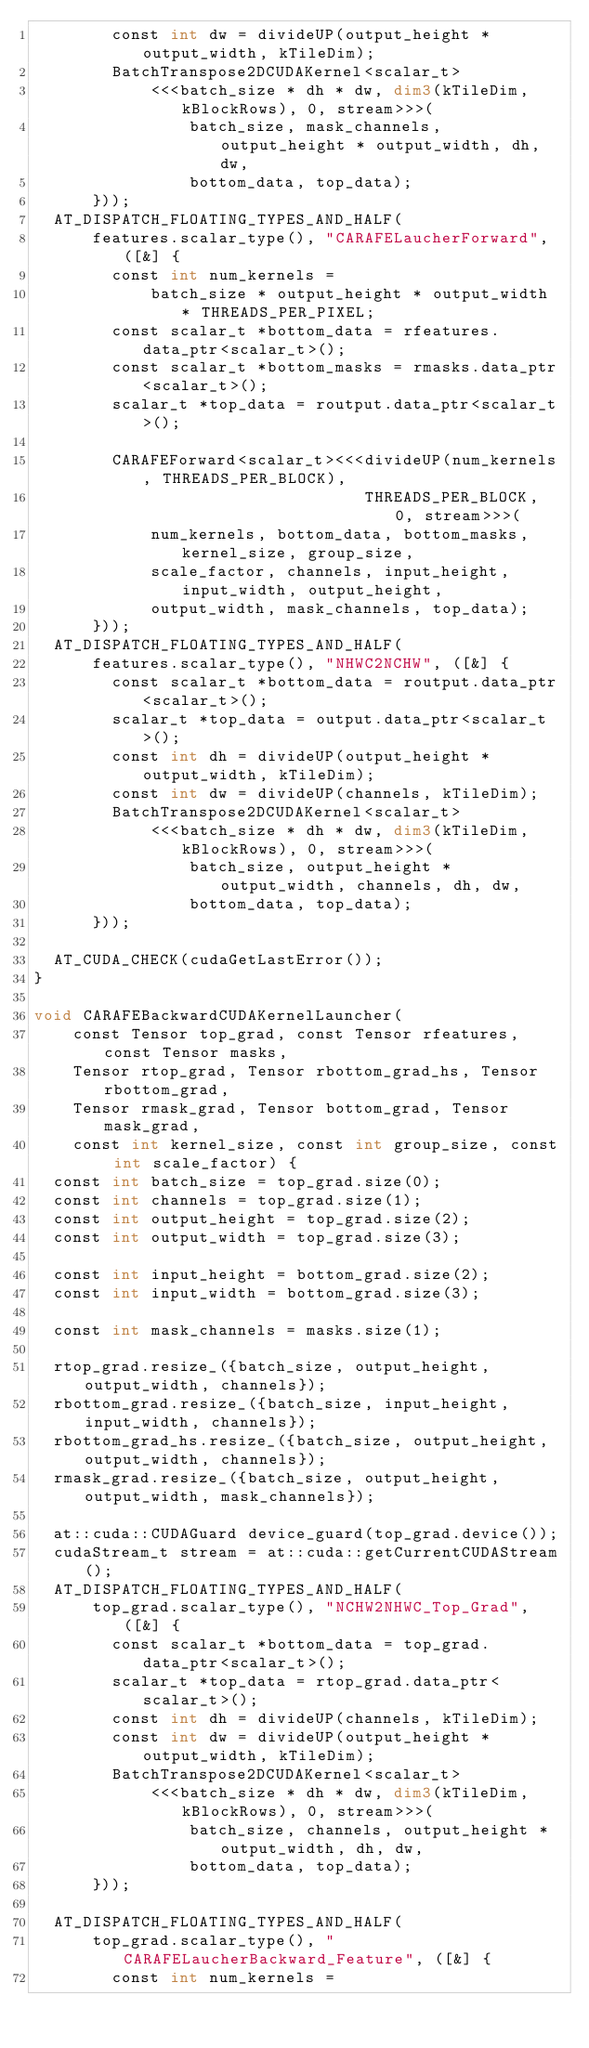<code> <loc_0><loc_0><loc_500><loc_500><_Cuda_>        const int dw = divideUP(output_height * output_width, kTileDim);
        BatchTranspose2DCUDAKernel<scalar_t>
            <<<batch_size * dh * dw, dim3(kTileDim, kBlockRows), 0, stream>>>(
                batch_size, mask_channels, output_height * output_width, dh, dw,
                bottom_data, top_data);
      }));
  AT_DISPATCH_FLOATING_TYPES_AND_HALF(
      features.scalar_type(), "CARAFELaucherForward", ([&] {
        const int num_kernels =
            batch_size * output_height * output_width * THREADS_PER_PIXEL;
        const scalar_t *bottom_data = rfeatures.data_ptr<scalar_t>();
        const scalar_t *bottom_masks = rmasks.data_ptr<scalar_t>();
        scalar_t *top_data = routput.data_ptr<scalar_t>();

        CARAFEForward<scalar_t><<<divideUP(num_kernels, THREADS_PER_BLOCK),
                                  THREADS_PER_BLOCK, 0, stream>>>(
            num_kernels, bottom_data, bottom_masks, kernel_size, group_size,
            scale_factor, channels, input_height, input_width, output_height,
            output_width, mask_channels, top_data);
      }));
  AT_DISPATCH_FLOATING_TYPES_AND_HALF(
      features.scalar_type(), "NHWC2NCHW", ([&] {
        const scalar_t *bottom_data = routput.data_ptr<scalar_t>();
        scalar_t *top_data = output.data_ptr<scalar_t>();
        const int dh = divideUP(output_height * output_width, kTileDim);
        const int dw = divideUP(channels, kTileDim);
        BatchTranspose2DCUDAKernel<scalar_t>
            <<<batch_size * dh * dw, dim3(kTileDim, kBlockRows), 0, stream>>>(
                batch_size, output_height * output_width, channels, dh, dw,
                bottom_data, top_data);
      }));

  AT_CUDA_CHECK(cudaGetLastError());
}

void CARAFEBackwardCUDAKernelLauncher(
    const Tensor top_grad, const Tensor rfeatures, const Tensor masks,
    Tensor rtop_grad, Tensor rbottom_grad_hs, Tensor rbottom_grad,
    Tensor rmask_grad, Tensor bottom_grad, Tensor mask_grad,
    const int kernel_size, const int group_size, const int scale_factor) {
  const int batch_size = top_grad.size(0);
  const int channels = top_grad.size(1);
  const int output_height = top_grad.size(2);
  const int output_width = top_grad.size(3);

  const int input_height = bottom_grad.size(2);
  const int input_width = bottom_grad.size(3);

  const int mask_channels = masks.size(1);

  rtop_grad.resize_({batch_size, output_height, output_width, channels});
  rbottom_grad.resize_({batch_size, input_height, input_width, channels});
  rbottom_grad_hs.resize_({batch_size, output_height, output_width, channels});
  rmask_grad.resize_({batch_size, output_height, output_width, mask_channels});

  at::cuda::CUDAGuard device_guard(top_grad.device());
  cudaStream_t stream = at::cuda::getCurrentCUDAStream();
  AT_DISPATCH_FLOATING_TYPES_AND_HALF(
      top_grad.scalar_type(), "NCHW2NHWC_Top_Grad", ([&] {
        const scalar_t *bottom_data = top_grad.data_ptr<scalar_t>();
        scalar_t *top_data = rtop_grad.data_ptr<scalar_t>();
        const int dh = divideUP(channels, kTileDim);
        const int dw = divideUP(output_height * output_width, kTileDim);
        BatchTranspose2DCUDAKernel<scalar_t>
            <<<batch_size * dh * dw, dim3(kTileDim, kBlockRows), 0, stream>>>(
                batch_size, channels, output_height * output_width, dh, dw,
                bottom_data, top_data);
      }));

  AT_DISPATCH_FLOATING_TYPES_AND_HALF(
      top_grad.scalar_type(), "CARAFELaucherBackward_Feature", ([&] {
        const int num_kernels =</code> 